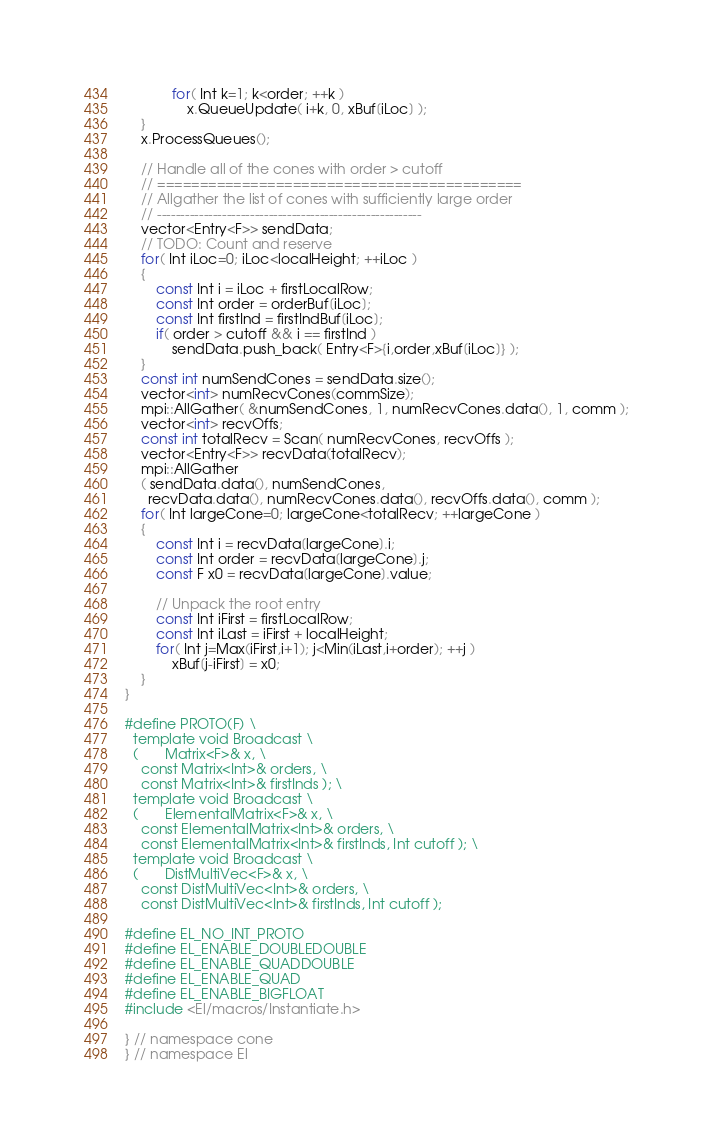<code> <loc_0><loc_0><loc_500><loc_500><_C++_>            for( Int k=1; k<order; ++k )
                x.QueueUpdate( i+k, 0, xBuf[iLoc] );
    }
    x.ProcessQueues();

    // Handle all of the cones with order > cutoff
    // ===========================================
    // Allgather the list of cones with sufficiently large order
    // ---------------------------------------------------------
    vector<Entry<F>> sendData;
    // TODO: Count and reserve
    for( Int iLoc=0; iLoc<localHeight; ++iLoc )
    {
        const Int i = iLoc + firstLocalRow;
        const Int order = orderBuf[iLoc];
        const Int firstInd = firstIndBuf[iLoc];
        if( order > cutoff && i == firstInd )
            sendData.push_back( Entry<F>{i,order,xBuf[iLoc]} );
    }
    const int numSendCones = sendData.size();
    vector<int> numRecvCones(commSize);
    mpi::AllGather( &numSendCones, 1, numRecvCones.data(), 1, comm );
    vector<int> recvOffs;
    const int totalRecv = Scan( numRecvCones, recvOffs ); 
    vector<Entry<F>> recvData(totalRecv);
    mpi::AllGather
    ( sendData.data(), numSendCones,
      recvData.data(), numRecvCones.data(), recvOffs.data(), comm );
    for( Int largeCone=0; largeCone<totalRecv; ++largeCone )
    {
        const Int i = recvData[largeCone].i;
        const Int order = recvData[largeCone].j;
        const F x0 = recvData[largeCone].value;

        // Unpack the root entry
        const Int iFirst = firstLocalRow;
        const Int iLast = iFirst + localHeight;
        for( Int j=Max(iFirst,i+1); j<Min(iLast,i+order); ++j )
            xBuf[j-iFirst] = x0;
    }
}

#define PROTO(F) \
  template void Broadcast \
  (       Matrix<F>& x, \
    const Matrix<Int>& orders, \
    const Matrix<Int>& firstInds ); \
  template void Broadcast \
  (       ElementalMatrix<F>& x, \
    const ElementalMatrix<Int>& orders, \
    const ElementalMatrix<Int>& firstInds, Int cutoff ); \
  template void Broadcast \
  (       DistMultiVec<F>& x, \
    const DistMultiVec<Int>& orders, \
    const DistMultiVec<Int>& firstInds, Int cutoff );

#define EL_NO_INT_PROTO
#define EL_ENABLE_DOUBLEDOUBLE
#define EL_ENABLE_QUADDOUBLE
#define EL_ENABLE_QUAD
#define EL_ENABLE_BIGFLOAT
#include <El/macros/Instantiate.h>

} // namespace cone
} // namespace El
</code> 